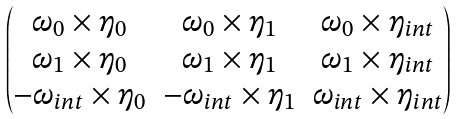Convert formula to latex. <formula><loc_0><loc_0><loc_500><loc_500>\begin{pmatrix} \omega _ { 0 } \times \eta _ { 0 } & \omega _ { 0 } \times \eta _ { 1 } & \omega _ { 0 } \times \eta _ { i n t } \\ \omega _ { 1 } \times \eta _ { 0 } & \omega _ { 1 } \times \eta _ { 1 } & \omega _ { 1 } \times \eta _ { i n t } \\ - \omega _ { i n t } \times \eta _ { 0 } & - \omega _ { i n t } \times \eta _ { 1 } & \omega _ { i n t } \times \eta _ { i n t } \end{pmatrix}</formula> 